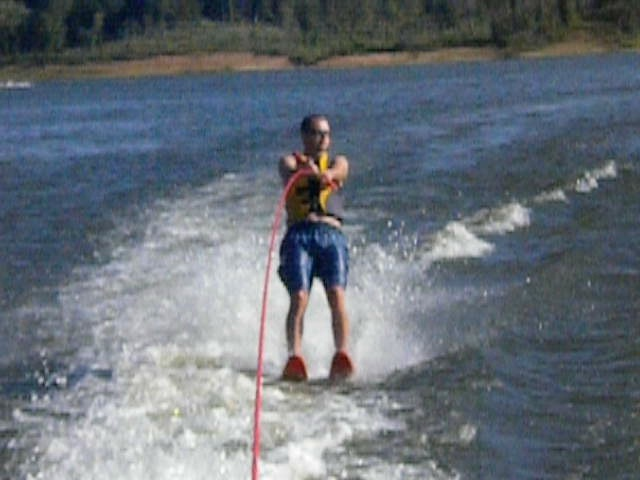Describe the objects in this image and their specific colors. I can see people in black, gray, navy, and maroon tones in this image. 